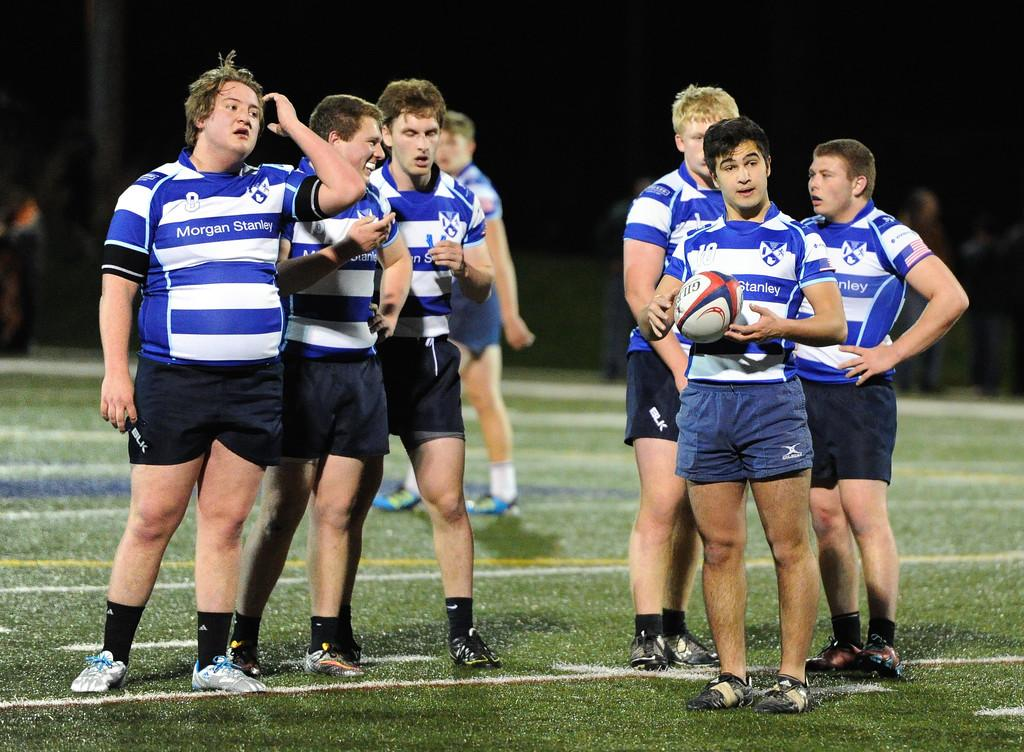Who or what can be seen in the image? There are people in the image. What type of terrain is visible in the image? There is grass in the image. How would you describe the lighting in the image? The background of the image is dark. Can you tell if there are people standing on the backside of the image? Some people may be standing on the backside of the image. What type of cork can be seen in the image? There is no cork present in the image. What is the secretary doing in the image? There is no mention of a secretary in the image, so it cannot be determined what they might be doing. 